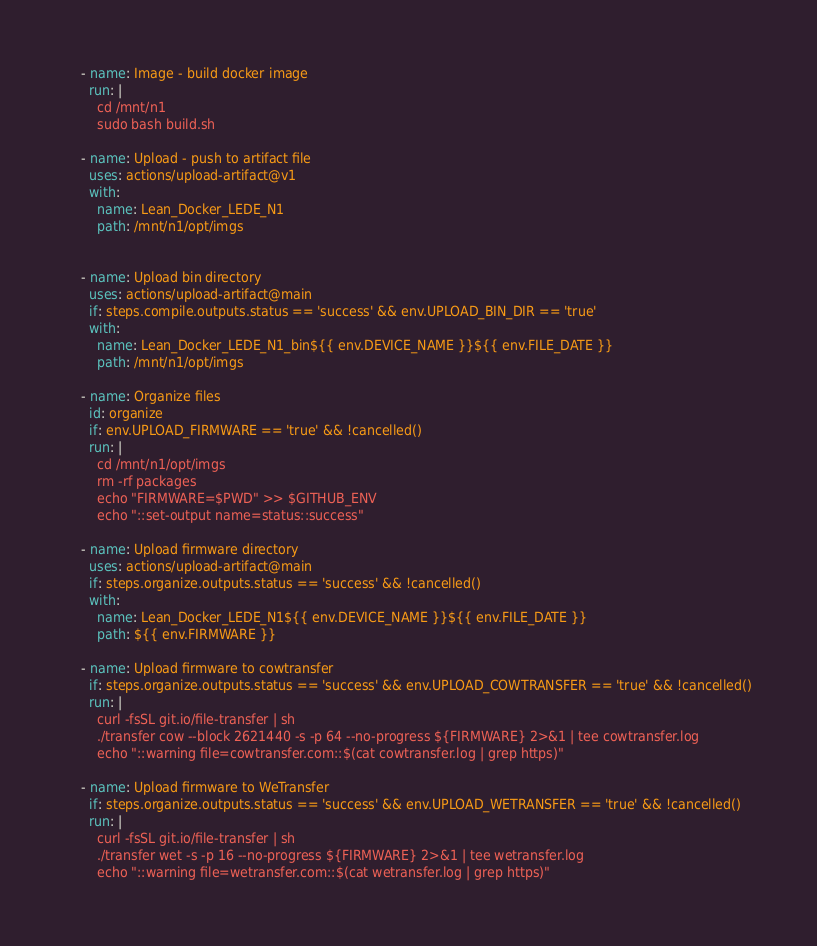Convert code to text. <code><loc_0><loc_0><loc_500><loc_500><_YAML_>
    - name: Image - build docker image
      run: |
        cd /mnt/n1
        sudo bash build.sh
        
    - name: Upload - push to artifact file
      uses: actions/upload-artifact@v1
      with:
        name: Lean_Docker_LEDE_N1
        path: /mnt/n1/opt/imgs


    - name: Upload bin directory
      uses: actions/upload-artifact@main
      if: steps.compile.outputs.status == 'success' && env.UPLOAD_BIN_DIR == 'true'
      with:
        name: Lean_Docker_LEDE_N1_bin${{ env.DEVICE_NAME }}${{ env.FILE_DATE }}
        path: /mnt/n1/opt/imgs

    - name: Organize files
      id: organize
      if: env.UPLOAD_FIRMWARE == 'true' && !cancelled()
      run: |
        cd /mnt/n1/opt/imgs
        rm -rf packages
        echo "FIRMWARE=$PWD" >> $GITHUB_ENV
        echo "::set-output name=status::success"

    - name: Upload firmware directory
      uses: actions/upload-artifact@main
      if: steps.organize.outputs.status == 'success' && !cancelled()
      with:
        name: Lean_Docker_LEDE_N1${{ env.DEVICE_NAME }}${{ env.FILE_DATE }}
        path: ${{ env.FIRMWARE }}

    - name: Upload firmware to cowtransfer
      if: steps.organize.outputs.status == 'success' && env.UPLOAD_COWTRANSFER == 'true' && !cancelled()
      run: |
        curl -fsSL git.io/file-transfer | sh
        ./transfer cow --block 2621440 -s -p 64 --no-progress ${FIRMWARE} 2>&1 | tee cowtransfer.log
        echo "::warning file=cowtransfer.com::$(cat cowtransfer.log | grep https)"

    - name: Upload firmware to WeTransfer
      if: steps.organize.outputs.status == 'success' && env.UPLOAD_WETRANSFER == 'true' && !cancelled()
      run: |
        curl -fsSL git.io/file-transfer | sh
        ./transfer wet -s -p 16 --no-progress ${FIRMWARE} 2>&1 | tee wetransfer.log
        echo "::warning file=wetransfer.com::$(cat wetransfer.log | grep https)"
</code> 